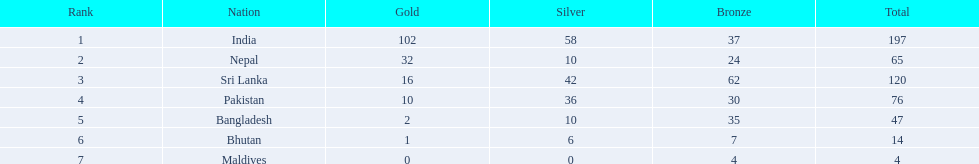Which nations secured medals? India, Nepal, Sri Lanka, Pakistan, Bangladesh, Bhutan, Maldives. Which secured the most? India. Which secured the least? Maldives. Could you parse the entire table? {'header': ['Rank', 'Nation', 'Gold', 'Silver', 'Bronze', 'Total'], 'rows': [['1', 'India', '102', '58', '37', '197'], ['2', 'Nepal', '32', '10', '24', '65'], ['3', 'Sri Lanka', '16', '42', '62', '120'], ['4', 'Pakistan', '10', '36', '30', '76'], ['5', 'Bangladesh', '2', '10', '35', '47'], ['6', 'Bhutan', '1', '6', '7', '14'], ['7', 'Maldives', '0', '0', '4', '4']]} 